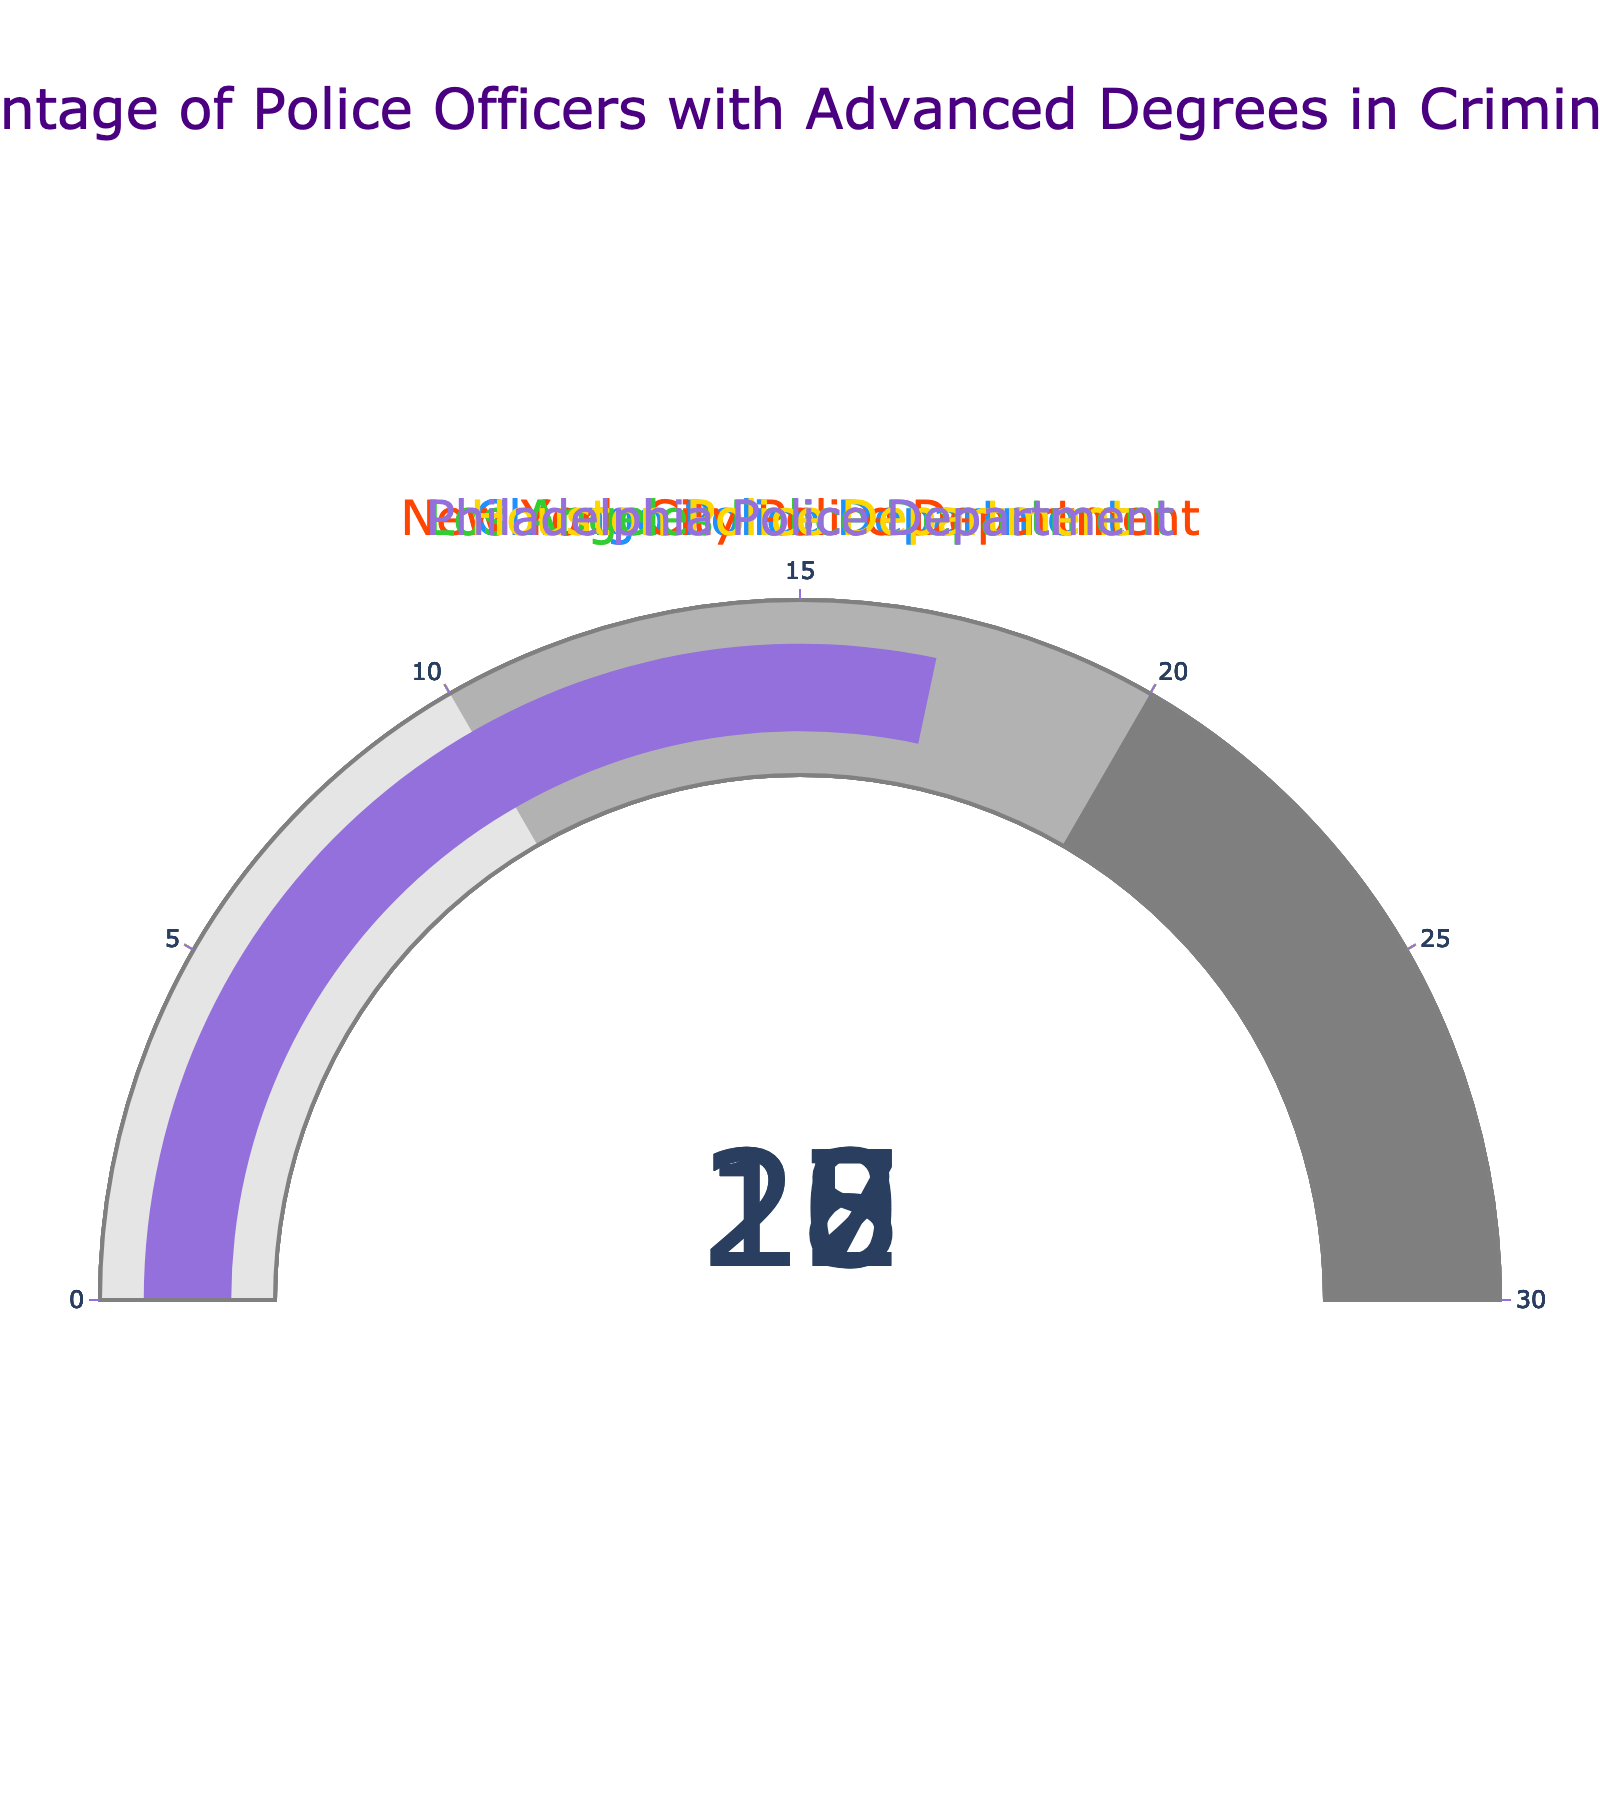what’s the percentage of police officers with advanced degrees in criminology for the Chicago Police Department? The gauge showing the percentage for the Chicago Police Department is marked at 18.
Answer: 18% Which department has the highest percentage of police officers with advanced degrees in criminology? By comparing all the gauges, the New York City Police Department has the highest percentage, indicated at 22.
Answer: New York City Police Department What is the difference in the percentage between the Los Angeles Police Department and the Houston Police Department? The Los Angeles Police Department has a percentage of 20, and the Houston Police Department has a percentage of 15. The difference is 20 - 15 = 5.
Answer: 5% What's the average percentage of police officers with advanced degrees across all listed departments? Add up the percentages: 18 (Chicago) + 22 (New York) + 20 (Los Angeles) + 15 (Houston) + 17 (Philadelphia) = 92. Then, divide by the number of departments: 92 / 5 = 18.4.
Answer: 18.4% If you combine the percentages of Chicago and Philadelphia Police Departments, does it exceed New York City's percentage? Chicago’s percentage is 18, and Philadelphia’s is 17. Combined, they are 18 + 17 = 35, which is greater than New York's 22.
Answer: Yes Which department has the lowest percentage of police officers with advanced degrees in criminology? By looking at the gauges, the Houston Police Department is the lowest with 15.
Answer: Houston Police Department How much higher is the New York City Police Department's percentage compared to the Philadelphia Police Department’s percentage? The New York City Police Department has 22 and the Philadelphia Police Department has 17. The difference is 22 - 17 = 5.
Answer: 5% What is the range of percentages among all listed police departments? The lowest percentage is 15 (Houston), and the highest is 22 (New York). The range is 22 - 15 = 7.
Answer: 7 What percentage of officers in Los Angeles Police Department have advanced degrees in criminology? The gauge for Los Angeles Police Department indicates 20.
Answer: 20% Is the Philadelphia Police Department's percentage closer to the Chicago Police Department's or the Houston Police Department’s? Philadelphia has 17, Chicago has 18 (17 - 18 = 1), and Houston has 15 (17 - 15 = 2). So, 17 is closer to 18 by a margin of 1.
Answer: Chicago Police Department 